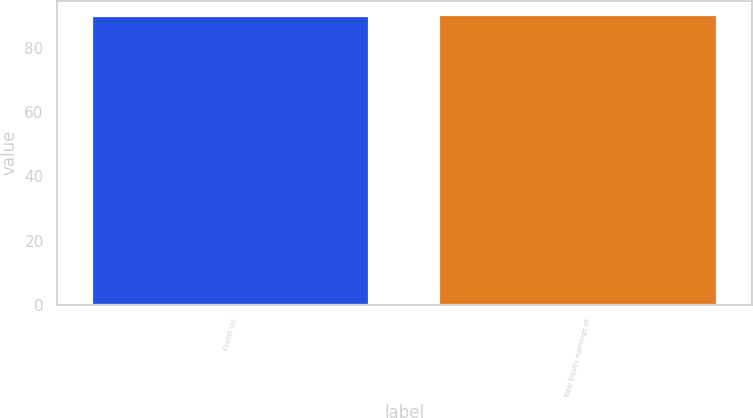Convert chart to OTSL. <chart><loc_0><loc_0><loc_500><loc_500><bar_chart><fcel>Foxtel (a)<fcel>Total Equity earnings of<nl><fcel>90<fcel>90.1<nl></chart> 